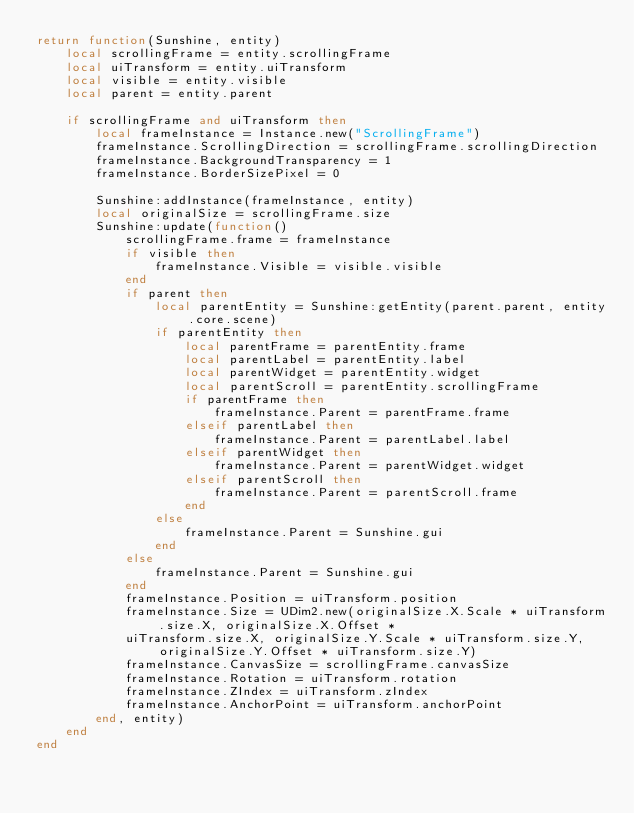Convert code to text. <code><loc_0><loc_0><loc_500><loc_500><_Lua_>return function(Sunshine, entity)
    local scrollingFrame = entity.scrollingFrame
    local uiTransform = entity.uiTransform
    local visible = entity.visible
    local parent = entity.parent

    if scrollingFrame and uiTransform then
        local frameInstance = Instance.new("ScrollingFrame")
        frameInstance.ScrollingDirection = scrollingFrame.scrollingDirection
        frameInstance.BackgroundTransparency = 1
        frameInstance.BorderSizePixel = 0
        
        Sunshine:addInstance(frameInstance, entity)
        local originalSize = scrollingFrame.size
        Sunshine:update(function()
            scrollingFrame.frame = frameInstance
            if visible then
                frameInstance.Visible = visible.visible
            end
            if parent then
                local parentEntity = Sunshine:getEntity(parent.parent, entity.core.scene)
                if parentEntity then
                    local parentFrame = parentEntity.frame
                    local parentLabel = parentEntity.label
                    local parentWidget = parentEntity.widget
                    local parentScroll = parentEntity.scrollingFrame
                    if parentFrame then
                        frameInstance.Parent = parentFrame.frame
                    elseif parentLabel then
                        frameInstance.Parent = parentLabel.label
                    elseif parentWidget then
                        frameInstance.Parent = parentWidget.widget
                    elseif parentScroll then
                        frameInstance.Parent = parentScroll.frame
                    end
                else
                    frameInstance.Parent = Sunshine.gui
                end
            else
                frameInstance.Parent = Sunshine.gui
            end
            frameInstance.Position = uiTransform.position
            frameInstance.Size = UDim2.new(originalSize.X.Scale * uiTransform.size.X, originalSize.X.Offset *
            uiTransform.size.X, originalSize.Y.Scale * uiTransform.size.Y, originalSize.Y.Offset * uiTransform.size.Y)
            frameInstance.CanvasSize = scrollingFrame.canvasSize
            frameInstance.Rotation = uiTransform.rotation
            frameInstance.ZIndex = uiTransform.zIndex
            frameInstance.AnchorPoint = uiTransform.anchorPoint
        end, entity)
    end
end</code> 